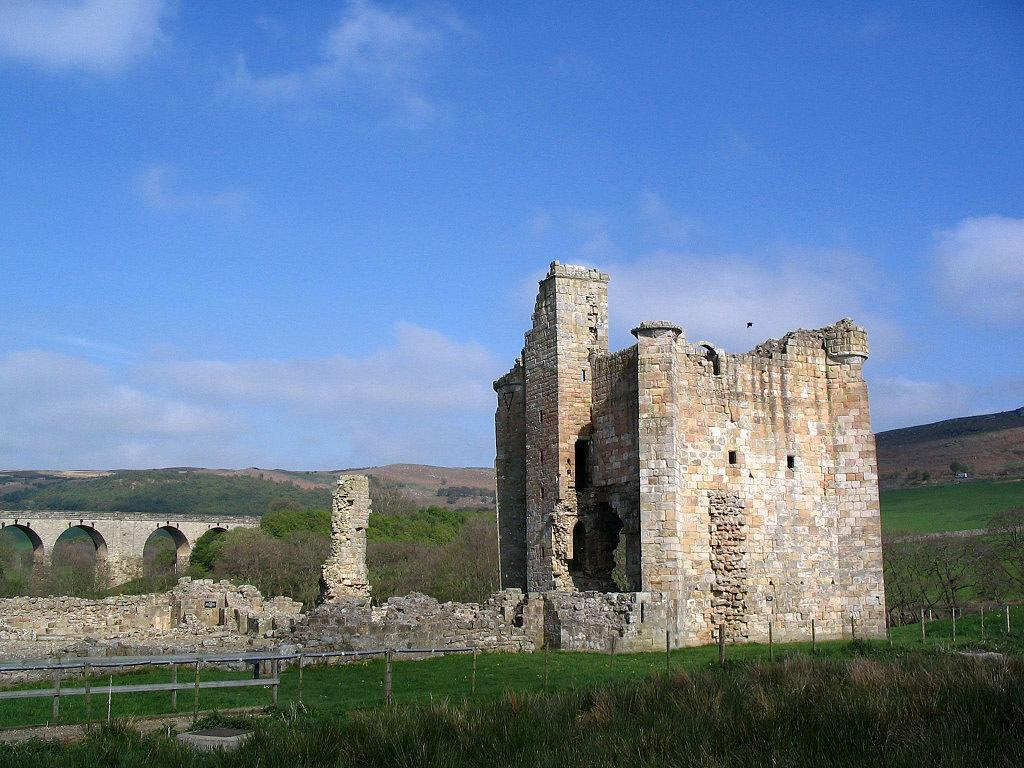What type of structures can be seen in the image? There are monuments in the image. What type of vegetation is present in the image? There is grass in the image. What are the poles used for in the image? The purpose of the poles is not specified, but they are visible in the image. What part of the natural environment is visible in the image? The ground and hills are visible in the image. What is visible in the sky in the image? The sky is visible in the image, and clouds are present. What type of flowers can be seen growing on the poles in the image? There are no flowers growing on the poles in the image; the poles are not described as having any vegetation. What type of soda is being served at the monument in the image? There is no mention of soda or any food or drink in the image. 